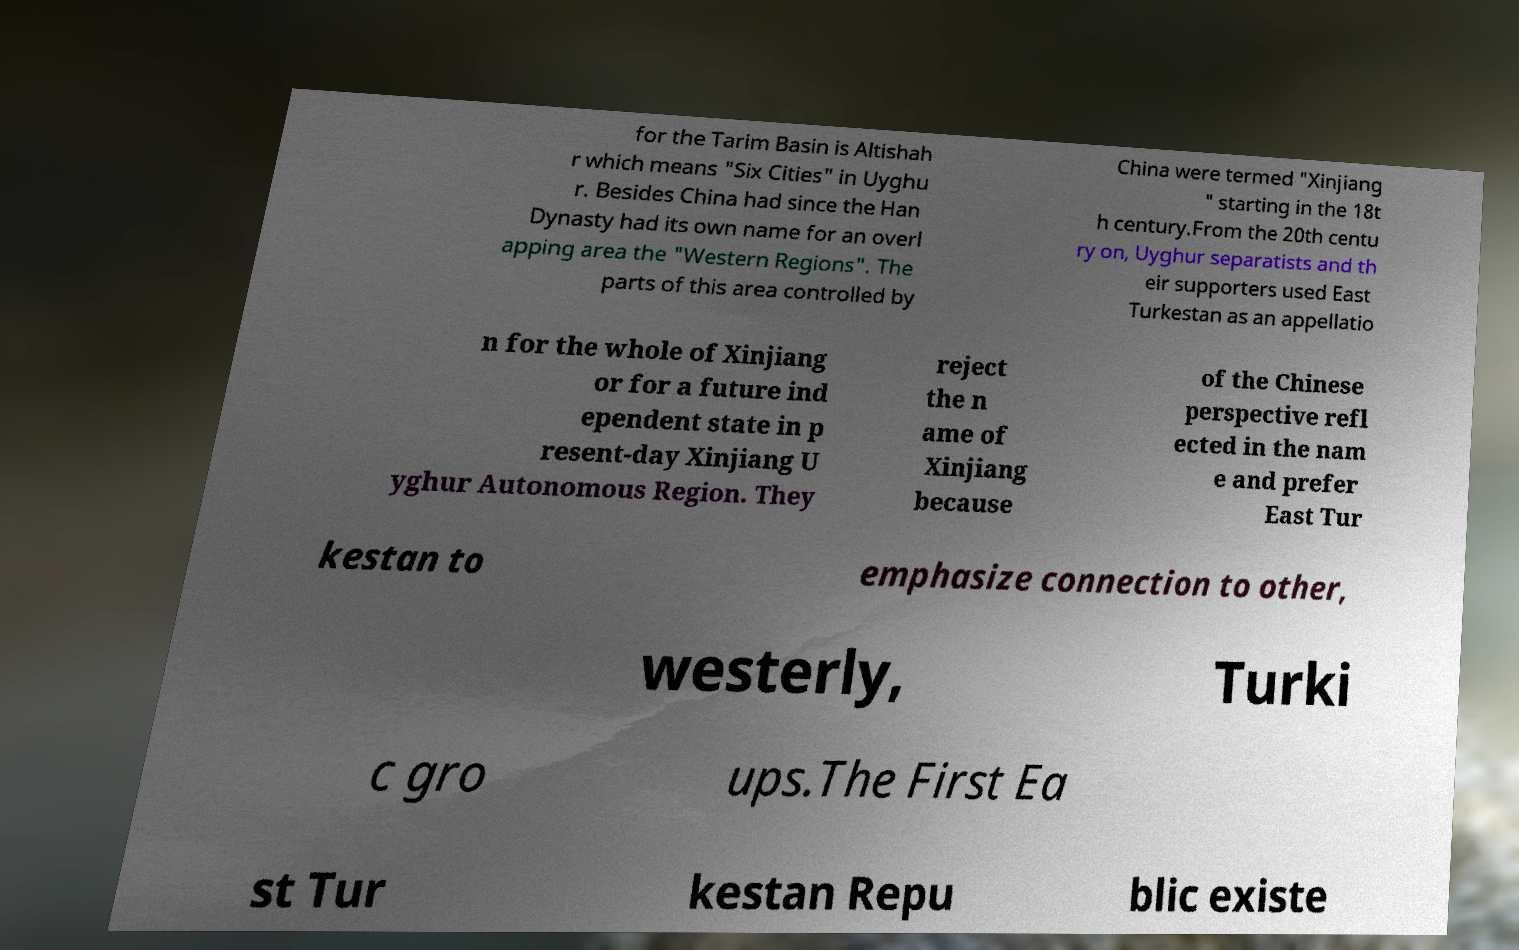Please identify and transcribe the text found in this image. for the Tarim Basin is Altishah r which means "Six Cities" in Uyghu r. Besides China had since the Han Dynasty had its own name for an overl apping area the "Western Regions". The parts of this area controlled by China were termed "Xinjiang " starting in the 18t h century.From the 20th centu ry on, Uyghur separatists and th eir supporters used East Turkestan as an appellatio n for the whole of Xinjiang or for a future ind ependent state in p resent-day Xinjiang U yghur Autonomous Region. They reject the n ame of Xinjiang because of the Chinese perspective refl ected in the nam e and prefer East Tur kestan to emphasize connection to other, westerly, Turki c gro ups.The First Ea st Tur kestan Repu blic existe 